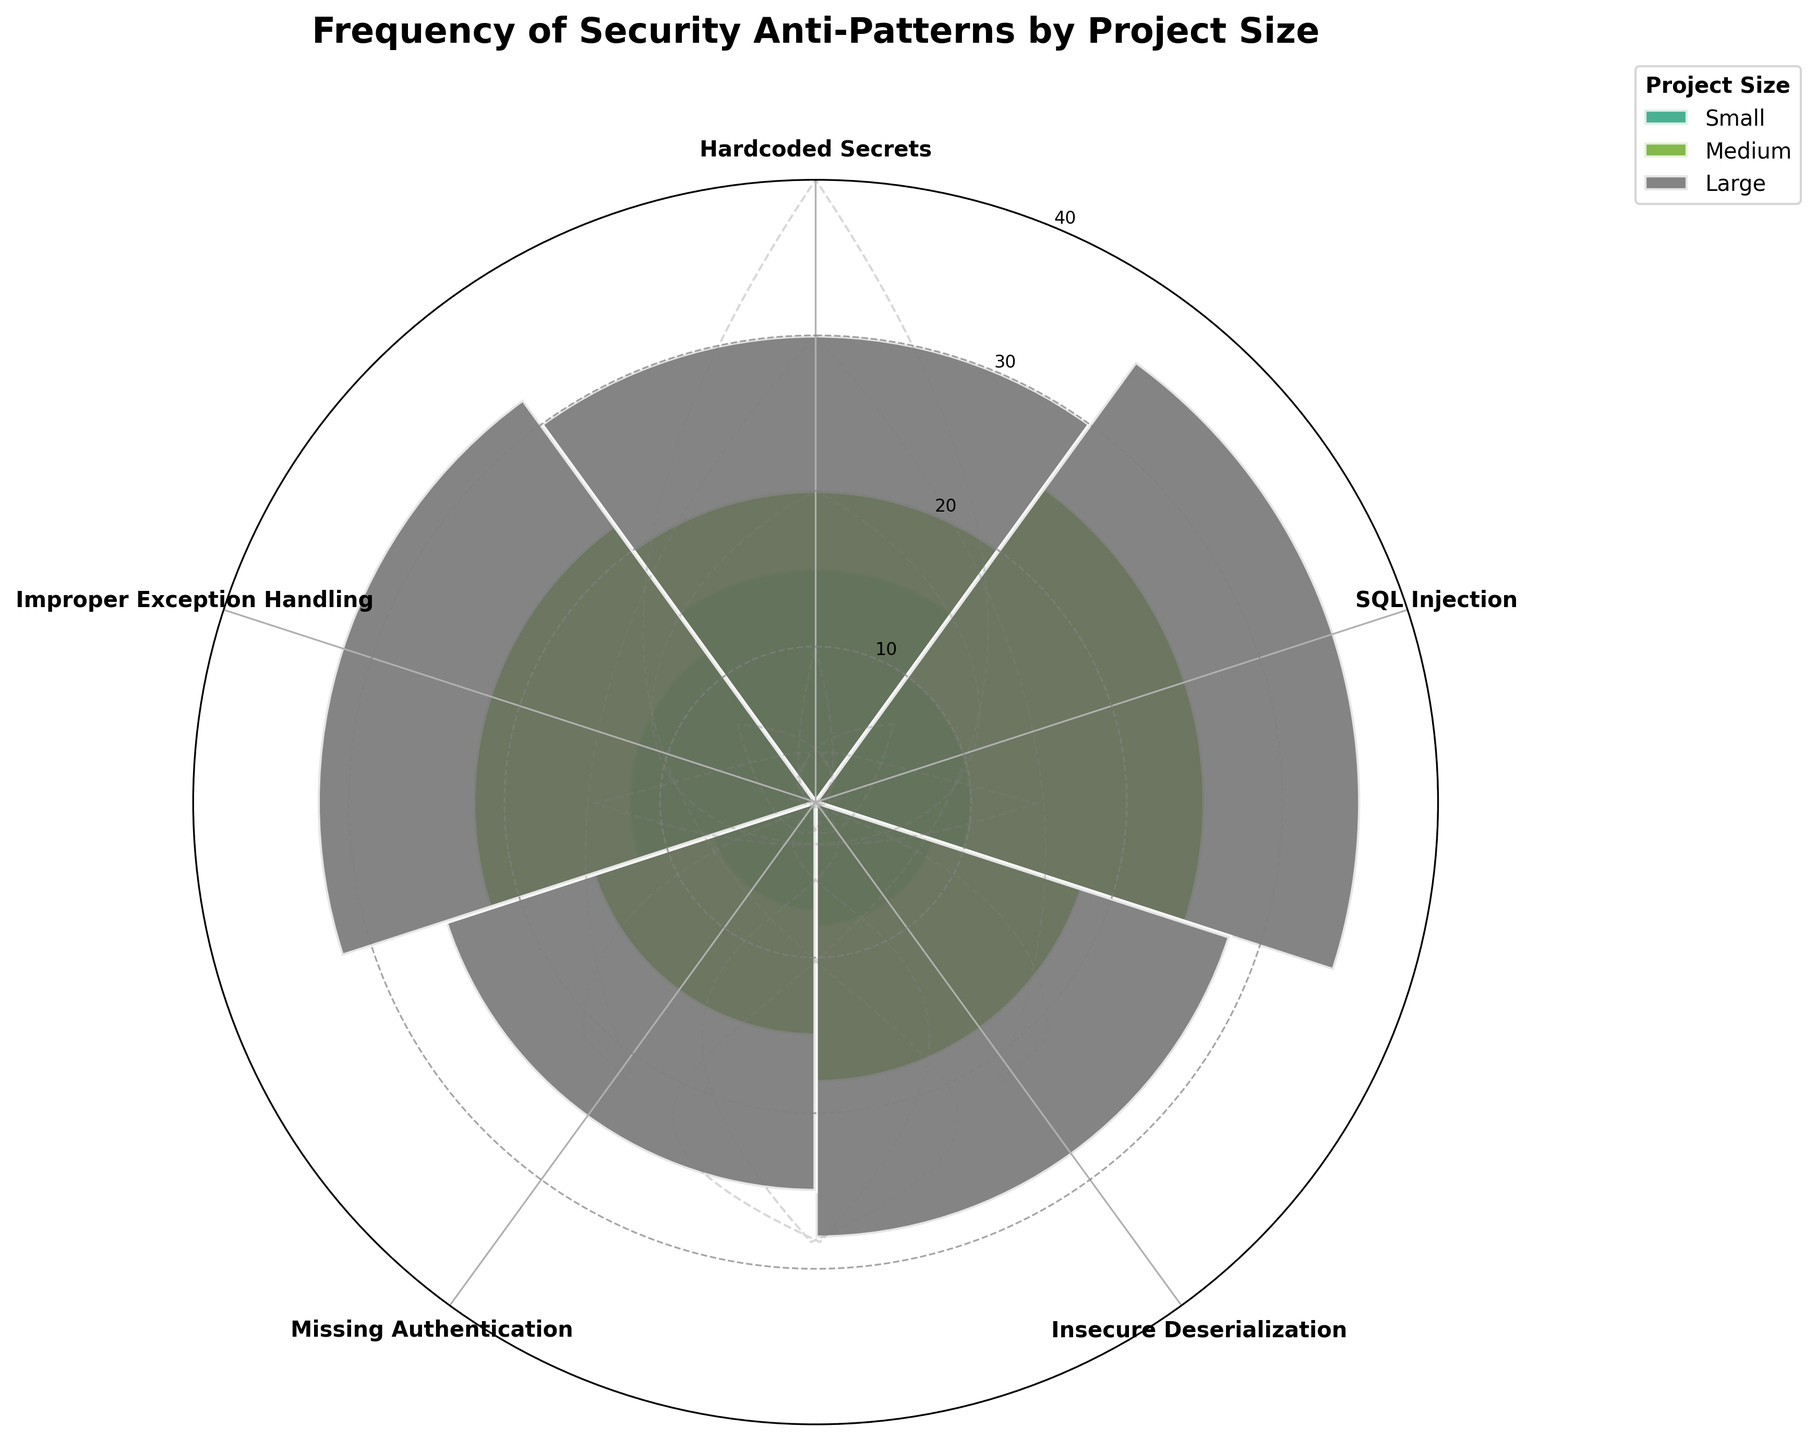What's the title of the plot? The title is displayed at the top of the chart. It summarizes the overall content of the plot.
Answer: Frequency of Security Anti-Patterns by Project Size How many project sizes are compared in the plot? The legend for the plot shows different categories for project sizes.
Answer: Three (Small, Medium, Large) Which anti-pattern has the highest frequency in Large projects? By referring to the bars associated with Large projects (typically coded by a distinct color from the legend) and identifying the tallest bar within the Large section.
Answer: SQL Injection What is the frequency of "Hardcoded Secrets" in Medium projects? Locate the Medium project bar for "Hardcoded Secrets" and read the value of its height.
Answer: 20 Which project size shows the lowest frequency for "Missing Authentication"? Locate the bar heights across the three project sizes for "Missing Authentication" and identify the shortest bar.
Answer: Small What's the difference in frequency of "SQL Injection" between Large and Small projects? Find the height of the "SQL Injection" bar for both Large and Small projects and subtract the Small value from the Large value.
Answer: 25 On average, what’s the frequency of "Improper Exception Handling" across all project sizes? Sum the frequencies of "Improper Exception Handling" from all the sizes and divide by the number of project sizes (3).
Answer: (12+22+32)/3 = 22 Which anti-pattern's frequency increases the most from Small to Large projects? Calculate the increase in frequencies for each anti-pattern from Small to Large projects, then identify the highest increase.
Answer: SQL Injection (35 - 10 = 25) How does the frequency of "Insecure Deserialization" compare between Medium and Large projects? Compare the heights of the bars for "Insecure Deserialization" between Medium and Large and articulate the difference.
Answer: Large > Medium What is the total sum of frequencies for "Hardcoded Secrets" across all project sizes? Add up the frequencies of "Hardcoded Secrets" for Small, Medium, and Large sizes.
Answer: 15 + 20 + 30 = 65 